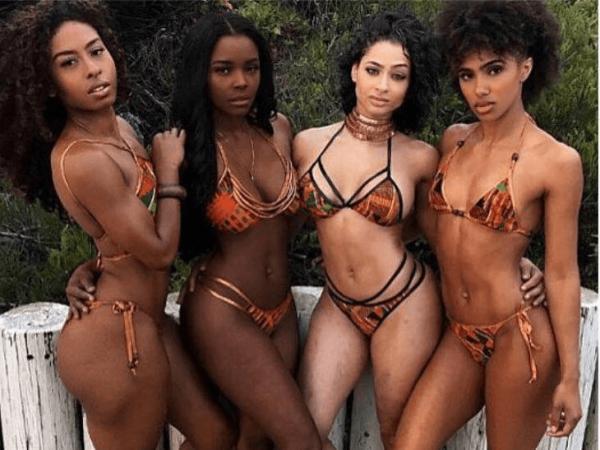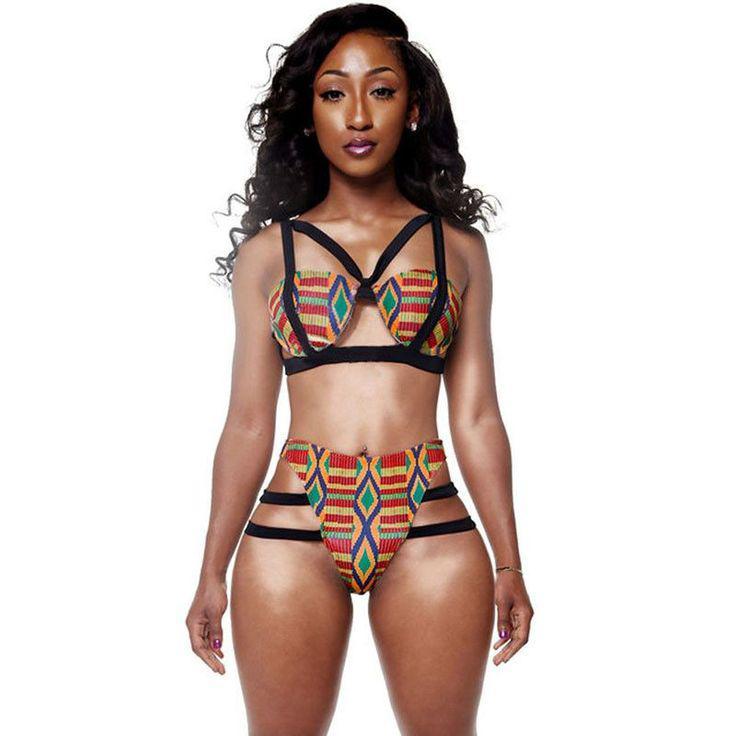The first image is the image on the left, the second image is the image on the right. Assess this claim about the two images: "There is a woman wearing a hat.". Correct or not? Answer yes or no. No. 